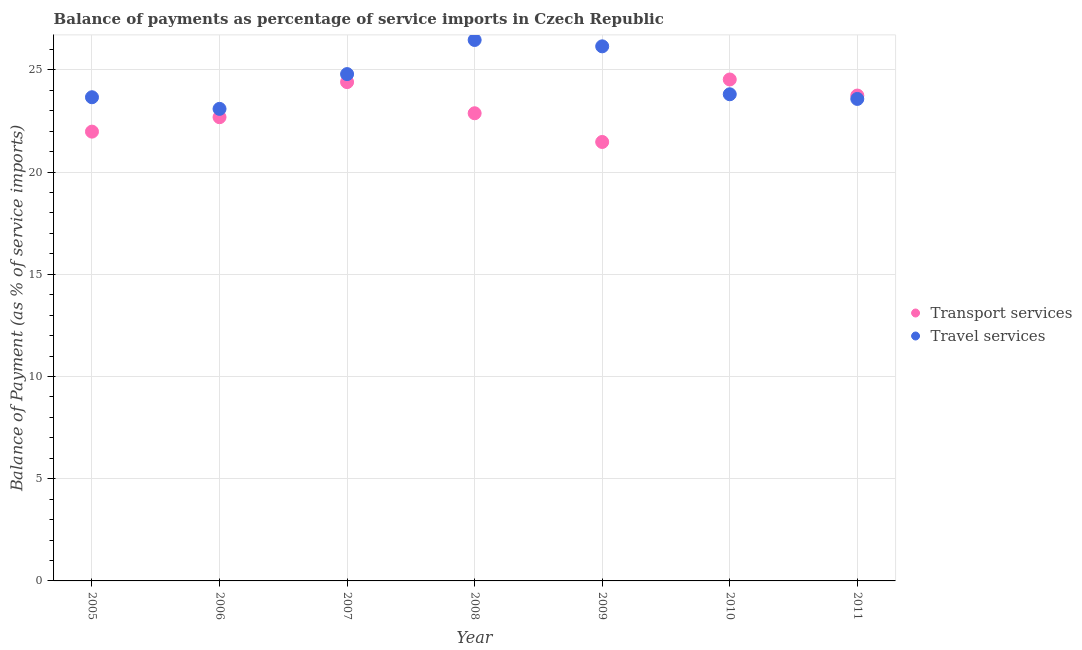What is the balance of payments of travel services in 2011?
Offer a terse response. 23.58. Across all years, what is the maximum balance of payments of transport services?
Make the answer very short. 24.53. Across all years, what is the minimum balance of payments of transport services?
Your answer should be compact. 21.47. What is the total balance of payments of transport services in the graph?
Your answer should be very brief. 161.68. What is the difference between the balance of payments of travel services in 2005 and that in 2007?
Provide a short and direct response. -1.13. What is the difference between the balance of payments of travel services in 2010 and the balance of payments of transport services in 2009?
Provide a short and direct response. 2.33. What is the average balance of payments of travel services per year?
Offer a terse response. 24.5. In the year 2009, what is the difference between the balance of payments of travel services and balance of payments of transport services?
Make the answer very short. 4.68. In how many years, is the balance of payments of travel services greater than 7 %?
Provide a short and direct response. 7. What is the ratio of the balance of payments of travel services in 2008 to that in 2009?
Provide a short and direct response. 1.01. Is the difference between the balance of payments of travel services in 2005 and 2007 greater than the difference between the balance of payments of transport services in 2005 and 2007?
Your response must be concise. Yes. What is the difference between the highest and the second highest balance of payments of transport services?
Your answer should be compact. 0.13. What is the difference between the highest and the lowest balance of payments of travel services?
Make the answer very short. 3.37. Does the balance of payments of transport services monotonically increase over the years?
Your response must be concise. No. Is the balance of payments of travel services strictly greater than the balance of payments of transport services over the years?
Ensure brevity in your answer.  No. How many dotlines are there?
Your response must be concise. 2. How many years are there in the graph?
Provide a succinct answer. 7. What is the difference between two consecutive major ticks on the Y-axis?
Provide a short and direct response. 5. Does the graph contain any zero values?
Offer a terse response. No. Does the graph contain grids?
Provide a short and direct response. Yes. How many legend labels are there?
Your response must be concise. 2. What is the title of the graph?
Offer a very short reply. Balance of payments as percentage of service imports in Czech Republic. What is the label or title of the Y-axis?
Provide a succinct answer. Balance of Payment (as % of service imports). What is the Balance of Payment (as % of service imports) of Transport services in 2005?
Your answer should be compact. 21.98. What is the Balance of Payment (as % of service imports) in Travel services in 2005?
Your answer should be very brief. 23.66. What is the Balance of Payment (as % of service imports) in Transport services in 2006?
Offer a very short reply. 22.68. What is the Balance of Payment (as % of service imports) in Travel services in 2006?
Provide a succinct answer. 23.09. What is the Balance of Payment (as % of service imports) of Transport services in 2007?
Ensure brevity in your answer.  24.4. What is the Balance of Payment (as % of service imports) in Travel services in 2007?
Provide a short and direct response. 24.79. What is the Balance of Payment (as % of service imports) in Transport services in 2008?
Ensure brevity in your answer.  22.88. What is the Balance of Payment (as % of service imports) in Travel services in 2008?
Keep it short and to the point. 26.46. What is the Balance of Payment (as % of service imports) of Transport services in 2009?
Provide a short and direct response. 21.47. What is the Balance of Payment (as % of service imports) of Travel services in 2009?
Your answer should be very brief. 26.15. What is the Balance of Payment (as % of service imports) in Transport services in 2010?
Offer a terse response. 24.53. What is the Balance of Payment (as % of service imports) of Travel services in 2010?
Offer a very short reply. 23.8. What is the Balance of Payment (as % of service imports) in Transport services in 2011?
Keep it short and to the point. 23.74. What is the Balance of Payment (as % of service imports) in Travel services in 2011?
Provide a short and direct response. 23.58. Across all years, what is the maximum Balance of Payment (as % of service imports) in Transport services?
Your answer should be very brief. 24.53. Across all years, what is the maximum Balance of Payment (as % of service imports) in Travel services?
Provide a succinct answer. 26.46. Across all years, what is the minimum Balance of Payment (as % of service imports) in Transport services?
Offer a very short reply. 21.47. Across all years, what is the minimum Balance of Payment (as % of service imports) of Travel services?
Offer a terse response. 23.09. What is the total Balance of Payment (as % of service imports) of Transport services in the graph?
Your answer should be compact. 161.68. What is the total Balance of Payment (as % of service imports) in Travel services in the graph?
Offer a very short reply. 171.53. What is the difference between the Balance of Payment (as % of service imports) in Transport services in 2005 and that in 2006?
Make the answer very short. -0.71. What is the difference between the Balance of Payment (as % of service imports) of Travel services in 2005 and that in 2006?
Keep it short and to the point. 0.57. What is the difference between the Balance of Payment (as % of service imports) of Transport services in 2005 and that in 2007?
Offer a very short reply. -2.42. What is the difference between the Balance of Payment (as % of service imports) of Travel services in 2005 and that in 2007?
Your answer should be very brief. -1.13. What is the difference between the Balance of Payment (as % of service imports) in Transport services in 2005 and that in 2008?
Keep it short and to the point. -0.9. What is the difference between the Balance of Payment (as % of service imports) of Travel services in 2005 and that in 2008?
Offer a very short reply. -2.8. What is the difference between the Balance of Payment (as % of service imports) in Transport services in 2005 and that in 2009?
Provide a short and direct response. 0.51. What is the difference between the Balance of Payment (as % of service imports) of Travel services in 2005 and that in 2009?
Offer a terse response. -2.49. What is the difference between the Balance of Payment (as % of service imports) in Transport services in 2005 and that in 2010?
Your answer should be very brief. -2.55. What is the difference between the Balance of Payment (as % of service imports) in Travel services in 2005 and that in 2010?
Make the answer very short. -0.15. What is the difference between the Balance of Payment (as % of service imports) of Transport services in 2005 and that in 2011?
Keep it short and to the point. -1.76. What is the difference between the Balance of Payment (as % of service imports) of Travel services in 2005 and that in 2011?
Ensure brevity in your answer.  0.08. What is the difference between the Balance of Payment (as % of service imports) of Transport services in 2006 and that in 2007?
Offer a terse response. -1.72. What is the difference between the Balance of Payment (as % of service imports) in Travel services in 2006 and that in 2007?
Make the answer very short. -1.7. What is the difference between the Balance of Payment (as % of service imports) of Transport services in 2006 and that in 2008?
Make the answer very short. -0.19. What is the difference between the Balance of Payment (as % of service imports) of Travel services in 2006 and that in 2008?
Keep it short and to the point. -3.37. What is the difference between the Balance of Payment (as % of service imports) of Transport services in 2006 and that in 2009?
Provide a short and direct response. 1.21. What is the difference between the Balance of Payment (as % of service imports) of Travel services in 2006 and that in 2009?
Provide a succinct answer. -3.06. What is the difference between the Balance of Payment (as % of service imports) in Transport services in 2006 and that in 2010?
Your answer should be very brief. -1.84. What is the difference between the Balance of Payment (as % of service imports) in Travel services in 2006 and that in 2010?
Make the answer very short. -0.71. What is the difference between the Balance of Payment (as % of service imports) of Transport services in 2006 and that in 2011?
Make the answer very short. -1.06. What is the difference between the Balance of Payment (as % of service imports) of Travel services in 2006 and that in 2011?
Offer a terse response. -0.49. What is the difference between the Balance of Payment (as % of service imports) in Transport services in 2007 and that in 2008?
Provide a short and direct response. 1.52. What is the difference between the Balance of Payment (as % of service imports) of Travel services in 2007 and that in 2008?
Keep it short and to the point. -1.67. What is the difference between the Balance of Payment (as % of service imports) of Transport services in 2007 and that in 2009?
Your answer should be very brief. 2.93. What is the difference between the Balance of Payment (as % of service imports) in Travel services in 2007 and that in 2009?
Your response must be concise. -1.36. What is the difference between the Balance of Payment (as % of service imports) of Transport services in 2007 and that in 2010?
Keep it short and to the point. -0.13. What is the difference between the Balance of Payment (as % of service imports) in Travel services in 2007 and that in 2010?
Give a very brief answer. 0.99. What is the difference between the Balance of Payment (as % of service imports) in Transport services in 2007 and that in 2011?
Provide a short and direct response. 0.66. What is the difference between the Balance of Payment (as % of service imports) in Travel services in 2007 and that in 2011?
Make the answer very short. 1.21. What is the difference between the Balance of Payment (as % of service imports) in Transport services in 2008 and that in 2009?
Your answer should be compact. 1.4. What is the difference between the Balance of Payment (as % of service imports) in Travel services in 2008 and that in 2009?
Offer a very short reply. 0.31. What is the difference between the Balance of Payment (as % of service imports) of Transport services in 2008 and that in 2010?
Offer a terse response. -1.65. What is the difference between the Balance of Payment (as % of service imports) of Travel services in 2008 and that in 2010?
Keep it short and to the point. 2.66. What is the difference between the Balance of Payment (as % of service imports) in Transport services in 2008 and that in 2011?
Ensure brevity in your answer.  -0.87. What is the difference between the Balance of Payment (as % of service imports) of Travel services in 2008 and that in 2011?
Offer a terse response. 2.88. What is the difference between the Balance of Payment (as % of service imports) in Transport services in 2009 and that in 2010?
Provide a short and direct response. -3.06. What is the difference between the Balance of Payment (as % of service imports) in Travel services in 2009 and that in 2010?
Your response must be concise. 2.34. What is the difference between the Balance of Payment (as % of service imports) in Transport services in 2009 and that in 2011?
Your response must be concise. -2.27. What is the difference between the Balance of Payment (as % of service imports) of Travel services in 2009 and that in 2011?
Your response must be concise. 2.57. What is the difference between the Balance of Payment (as % of service imports) in Transport services in 2010 and that in 2011?
Give a very brief answer. 0.79. What is the difference between the Balance of Payment (as % of service imports) in Travel services in 2010 and that in 2011?
Keep it short and to the point. 0.23. What is the difference between the Balance of Payment (as % of service imports) in Transport services in 2005 and the Balance of Payment (as % of service imports) in Travel services in 2006?
Your answer should be compact. -1.11. What is the difference between the Balance of Payment (as % of service imports) in Transport services in 2005 and the Balance of Payment (as % of service imports) in Travel services in 2007?
Ensure brevity in your answer.  -2.81. What is the difference between the Balance of Payment (as % of service imports) of Transport services in 2005 and the Balance of Payment (as % of service imports) of Travel services in 2008?
Your answer should be very brief. -4.48. What is the difference between the Balance of Payment (as % of service imports) of Transport services in 2005 and the Balance of Payment (as % of service imports) of Travel services in 2009?
Ensure brevity in your answer.  -4.17. What is the difference between the Balance of Payment (as % of service imports) of Transport services in 2005 and the Balance of Payment (as % of service imports) of Travel services in 2010?
Your answer should be compact. -1.83. What is the difference between the Balance of Payment (as % of service imports) in Transport services in 2005 and the Balance of Payment (as % of service imports) in Travel services in 2011?
Keep it short and to the point. -1.6. What is the difference between the Balance of Payment (as % of service imports) of Transport services in 2006 and the Balance of Payment (as % of service imports) of Travel services in 2007?
Your answer should be very brief. -2.11. What is the difference between the Balance of Payment (as % of service imports) in Transport services in 2006 and the Balance of Payment (as % of service imports) in Travel services in 2008?
Provide a succinct answer. -3.78. What is the difference between the Balance of Payment (as % of service imports) of Transport services in 2006 and the Balance of Payment (as % of service imports) of Travel services in 2009?
Make the answer very short. -3.47. What is the difference between the Balance of Payment (as % of service imports) in Transport services in 2006 and the Balance of Payment (as % of service imports) in Travel services in 2010?
Make the answer very short. -1.12. What is the difference between the Balance of Payment (as % of service imports) of Transport services in 2006 and the Balance of Payment (as % of service imports) of Travel services in 2011?
Your answer should be very brief. -0.89. What is the difference between the Balance of Payment (as % of service imports) in Transport services in 2007 and the Balance of Payment (as % of service imports) in Travel services in 2008?
Give a very brief answer. -2.06. What is the difference between the Balance of Payment (as % of service imports) of Transport services in 2007 and the Balance of Payment (as % of service imports) of Travel services in 2009?
Your answer should be compact. -1.75. What is the difference between the Balance of Payment (as % of service imports) of Transport services in 2007 and the Balance of Payment (as % of service imports) of Travel services in 2010?
Your answer should be very brief. 0.59. What is the difference between the Balance of Payment (as % of service imports) of Transport services in 2007 and the Balance of Payment (as % of service imports) of Travel services in 2011?
Your response must be concise. 0.82. What is the difference between the Balance of Payment (as % of service imports) in Transport services in 2008 and the Balance of Payment (as % of service imports) in Travel services in 2009?
Your answer should be compact. -3.27. What is the difference between the Balance of Payment (as % of service imports) of Transport services in 2008 and the Balance of Payment (as % of service imports) of Travel services in 2010?
Your response must be concise. -0.93. What is the difference between the Balance of Payment (as % of service imports) in Transport services in 2008 and the Balance of Payment (as % of service imports) in Travel services in 2011?
Provide a succinct answer. -0.7. What is the difference between the Balance of Payment (as % of service imports) in Transport services in 2009 and the Balance of Payment (as % of service imports) in Travel services in 2010?
Keep it short and to the point. -2.33. What is the difference between the Balance of Payment (as % of service imports) in Transport services in 2009 and the Balance of Payment (as % of service imports) in Travel services in 2011?
Your response must be concise. -2.11. What is the difference between the Balance of Payment (as % of service imports) of Transport services in 2010 and the Balance of Payment (as % of service imports) of Travel services in 2011?
Your answer should be very brief. 0.95. What is the average Balance of Payment (as % of service imports) in Transport services per year?
Offer a very short reply. 23.1. What is the average Balance of Payment (as % of service imports) of Travel services per year?
Offer a very short reply. 24.5. In the year 2005, what is the difference between the Balance of Payment (as % of service imports) in Transport services and Balance of Payment (as % of service imports) in Travel services?
Your answer should be compact. -1.68. In the year 2006, what is the difference between the Balance of Payment (as % of service imports) of Transport services and Balance of Payment (as % of service imports) of Travel services?
Ensure brevity in your answer.  -0.41. In the year 2007, what is the difference between the Balance of Payment (as % of service imports) in Transport services and Balance of Payment (as % of service imports) in Travel services?
Provide a short and direct response. -0.39. In the year 2008, what is the difference between the Balance of Payment (as % of service imports) in Transport services and Balance of Payment (as % of service imports) in Travel services?
Provide a succinct answer. -3.58. In the year 2009, what is the difference between the Balance of Payment (as % of service imports) of Transport services and Balance of Payment (as % of service imports) of Travel services?
Your answer should be compact. -4.68. In the year 2010, what is the difference between the Balance of Payment (as % of service imports) of Transport services and Balance of Payment (as % of service imports) of Travel services?
Ensure brevity in your answer.  0.72. In the year 2011, what is the difference between the Balance of Payment (as % of service imports) of Transport services and Balance of Payment (as % of service imports) of Travel services?
Your answer should be very brief. 0.17. What is the ratio of the Balance of Payment (as % of service imports) in Transport services in 2005 to that in 2006?
Offer a terse response. 0.97. What is the ratio of the Balance of Payment (as % of service imports) in Travel services in 2005 to that in 2006?
Your answer should be very brief. 1.02. What is the ratio of the Balance of Payment (as % of service imports) in Transport services in 2005 to that in 2007?
Provide a short and direct response. 0.9. What is the ratio of the Balance of Payment (as % of service imports) of Travel services in 2005 to that in 2007?
Your answer should be compact. 0.95. What is the ratio of the Balance of Payment (as % of service imports) in Transport services in 2005 to that in 2008?
Your answer should be very brief. 0.96. What is the ratio of the Balance of Payment (as % of service imports) of Travel services in 2005 to that in 2008?
Provide a short and direct response. 0.89. What is the ratio of the Balance of Payment (as % of service imports) of Transport services in 2005 to that in 2009?
Offer a terse response. 1.02. What is the ratio of the Balance of Payment (as % of service imports) of Travel services in 2005 to that in 2009?
Keep it short and to the point. 0.9. What is the ratio of the Balance of Payment (as % of service imports) in Transport services in 2005 to that in 2010?
Keep it short and to the point. 0.9. What is the ratio of the Balance of Payment (as % of service imports) in Transport services in 2005 to that in 2011?
Your response must be concise. 0.93. What is the ratio of the Balance of Payment (as % of service imports) in Transport services in 2006 to that in 2007?
Keep it short and to the point. 0.93. What is the ratio of the Balance of Payment (as % of service imports) of Travel services in 2006 to that in 2007?
Ensure brevity in your answer.  0.93. What is the ratio of the Balance of Payment (as % of service imports) of Transport services in 2006 to that in 2008?
Give a very brief answer. 0.99. What is the ratio of the Balance of Payment (as % of service imports) in Travel services in 2006 to that in 2008?
Keep it short and to the point. 0.87. What is the ratio of the Balance of Payment (as % of service imports) of Transport services in 2006 to that in 2009?
Your response must be concise. 1.06. What is the ratio of the Balance of Payment (as % of service imports) in Travel services in 2006 to that in 2009?
Provide a short and direct response. 0.88. What is the ratio of the Balance of Payment (as % of service imports) in Transport services in 2006 to that in 2010?
Your answer should be very brief. 0.92. What is the ratio of the Balance of Payment (as % of service imports) of Travel services in 2006 to that in 2010?
Make the answer very short. 0.97. What is the ratio of the Balance of Payment (as % of service imports) of Transport services in 2006 to that in 2011?
Give a very brief answer. 0.96. What is the ratio of the Balance of Payment (as % of service imports) of Travel services in 2006 to that in 2011?
Give a very brief answer. 0.98. What is the ratio of the Balance of Payment (as % of service imports) in Transport services in 2007 to that in 2008?
Ensure brevity in your answer.  1.07. What is the ratio of the Balance of Payment (as % of service imports) of Travel services in 2007 to that in 2008?
Make the answer very short. 0.94. What is the ratio of the Balance of Payment (as % of service imports) of Transport services in 2007 to that in 2009?
Offer a terse response. 1.14. What is the ratio of the Balance of Payment (as % of service imports) of Travel services in 2007 to that in 2009?
Keep it short and to the point. 0.95. What is the ratio of the Balance of Payment (as % of service imports) in Travel services in 2007 to that in 2010?
Keep it short and to the point. 1.04. What is the ratio of the Balance of Payment (as % of service imports) of Transport services in 2007 to that in 2011?
Offer a very short reply. 1.03. What is the ratio of the Balance of Payment (as % of service imports) in Travel services in 2007 to that in 2011?
Make the answer very short. 1.05. What is the ratio of the Balance of Payment (as % of service imports) in Transport services in 2008 to that in 2009?
Offer a very short reply. 1.07. What is the ratio of the Balance of Payment (as % of service imports) of Travel services in 2008 to that in 2009?
Keep it short and to the point. 1.01. What is the ratio of the Balance of Payment (as % of service imports) in Transport services in 2008 to that in 2010?
Your response must be concise. 0.93. What is the ratio of the Balance of Payment (as % of service imports) of Travel services in 2008 to that in 2010?
Provide a short and direct response. 1.11. What is the ratio of the Balance of Payment (as % of service imports) in Transport services in 2008 to that in 2011?
Offer a terse response. 0.96. What is the ratio of the Balance of Payment (as % of service imports) in Travel services in 2008 to that in 2011?
Offer a very short reply. 1.12. What is the ratio of the Balance of Payment (as % of service imports) in Transport services in 2009 to that in 2010?
Provide a short and direct response. 0.88. What is the ratio of the Balance of Payment (as % of service imports) of Travel services in 2009 to that in 2010?
Your answer should be compact. 1.1. What is the ratio of the Balance of Payment (as % of service imports) of Transport services in 2009 to that in 2011?
Ensure brevity in your answer.  0.9. What is the ratio of the Balance of Payment (as % of service imports) in Travel services in 2009 to that in 2011?
Provide a short and direct response. 1.11. What is the ratio of the Balance of Payment (as % of service imports) of Transport services in 2010 to that in 2011?
Offer a very short reply. 1.03. What is the ratio of the Balance of Payment (as % of service imports) of Travel services in 2010 to that in 2011?
Provide a succinct answer. 1.01. What is the difference between the highest and the second highest Balance of Payment (as % of service imports) in Transport services?
Your answer should be compact. 0.13. What is the difference between the highest and the second highest Balance of Payment (as % of service imports) of Travel services?
Make the answer very short. 0.31. What is the difference between the highest and the lowest Balance of Payment (as % of service imports) in Transport services?
Offer a very short reply. 3.06. What is the difference between the highest and the lowest Balance of Payment (as % of service imports) of Travel services?
Offer a terse response. 3.37. 